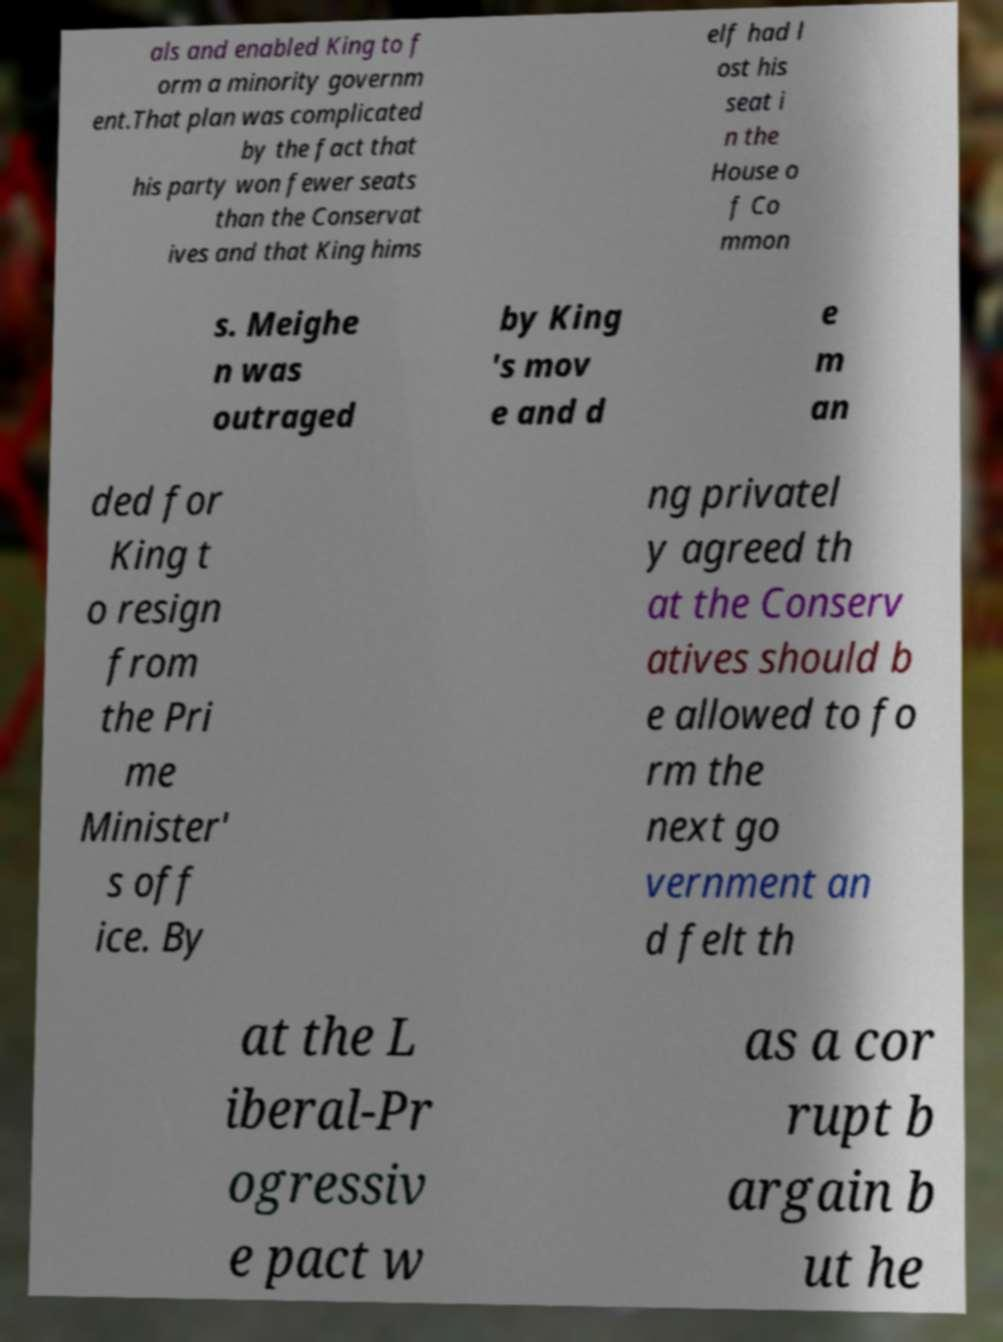Can you read and provide the text displayed in the image?This photo seems to have some interesting text. Can you extract and type it out for me? als and enabled King to f orm a minority governm ent.That plan was complicated by the fact that his party won fewer seats than the Conservat ives and that King hims elf had l ost his seat i n the House o f Co mmon s. Meighe n was outraged by King 's mov e and d e m an ded for King t o resign from the Pri me Minister' s off ice. By ng privatel y agreed th at the Conserv atives should b e allowed to fo rm the next go vernment an d felt th at the L iberal-Pr ogressiv e pact w as a cor rupt b argain b ut he 